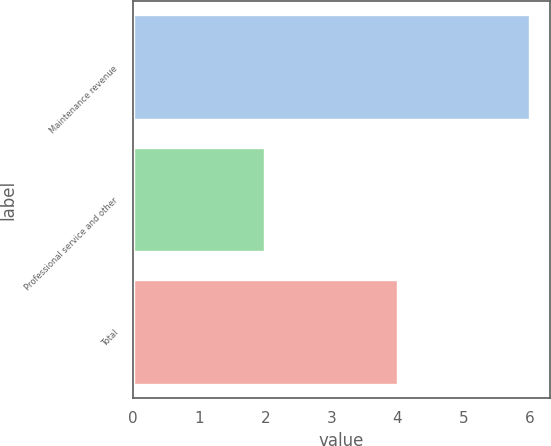Convert chart to OTSL. <chart><loc_0><loc_0><loc_500><loc_500><bar_chart><fcel>Maintenance revenue<fcel>Professional service and other<fcel>Total<nl><fcel>6<fcel>2<fcel>4<nl></chart> 